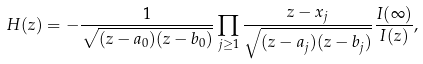Convert formula to latex. <formula><loc_0><loc_0><loc_500><loc_500>H ( z ) = - \frac { 1 } { \sqrt { ( z - a _ { 0 } ) ( z - b _ { 0 } ) } } \prod _ { j \geq 1 } \frac { z - x _ { j } } { \sqrt { ( z - a _ { j } ) ( z - b _ { j } ) } } \frac { I ( \infty ) } { I ( z ) } ,</formula> 